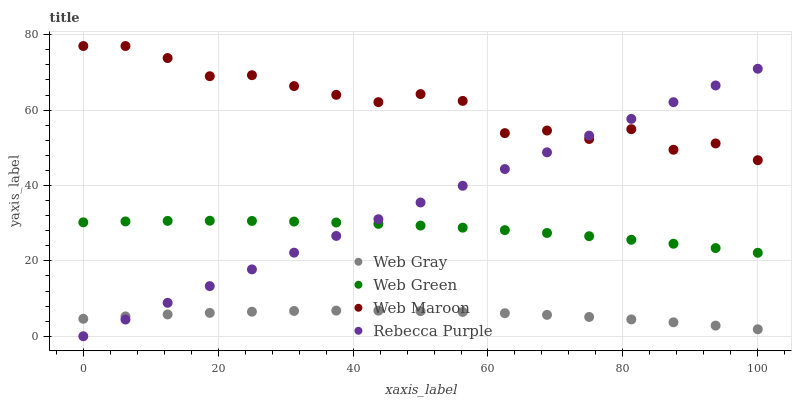Does Web Gray have the minimum area under the curve?
Answer yes or no. Yes. Does Web Maroon have the maximum area under the curve?
Answer yes or no. Yes. Does Rebecca Purple have the minimum area under the curve?
Answer yes or no. No. Does Rebecca Purple have the maximum area under the curve?
Answer yes or no. No. Is Rebecca Purple the smoothest?
Answer yes or no. Yes. Is Web Maroon the roughest?
Answer yes or no. Yes. Is Web Maroon the smoothest?
Answer yes or no. No. Is Rebecca Purple the roughest?
Answer yes or no. No. Does Rebecca Purple have the lowest value?
Answer yes or no. Yes. Does Web Maroon have the lowest value?
Answer yes or no. No. Does Web Maroon have the highest value?
Answer yes or no. Yes. Does Rebecca Purple have the highest value?
Answer yes or no. No. Is Web Gray less than Web Green?
Answer yes or no. Yes. Is Web Maroon greater than Web Gray?
Answer yes or no. Yes. Does Rebecca Purple intersect Web Gray?
Answer yes or no. Yes. Is Rebecca Purple less than Web Gray?
Answer yes or no. No. Is Rebecca Purple greater than Web Gray?
Answer yes or no. No. Does Web Gray intersect Web Green?
Answer yes or no. No. 